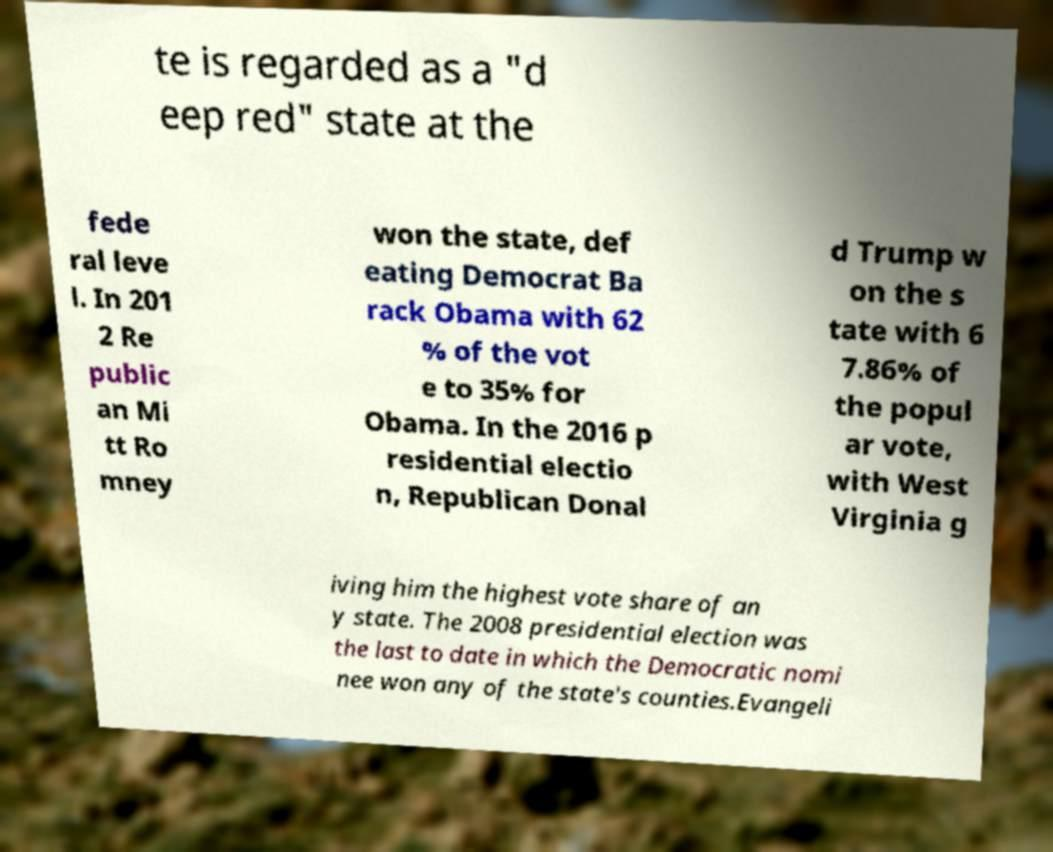What messages or text are displayed in this image? I need them in a readable, typed format. te is regarded as a "d eep red" state at the fede ral leve l. In 201 2 Re public an Mi tt Ro mney won the state, def eating Democrat Ba rack Obama with 62 % of the vot e to 35% for Obama. In the 2016 p residential electio n, Republican Donal d Trump w on the s tate with 6 7.86% of the popul ar vote, with West Virginia g iving him the highest vote share of an y state. The 2008 presidential election was the last to date in which the Democratic nomi nee won any of the state's counties.Evangeli 